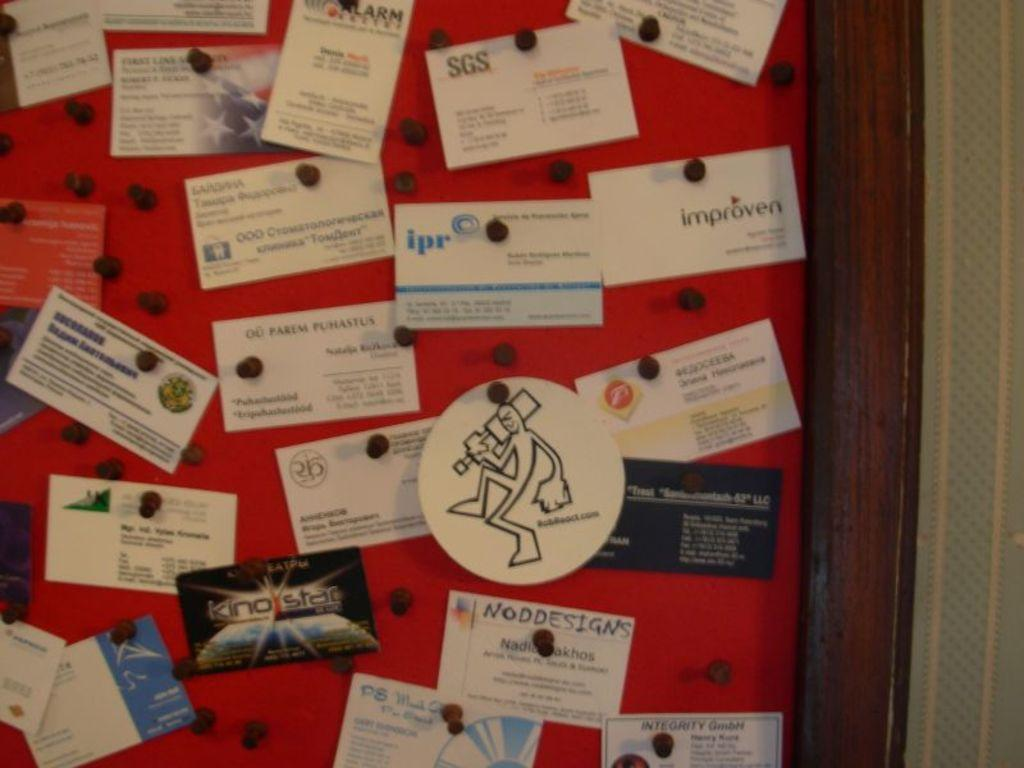<image>
Present a compact description of the photo's key features. A bulletin board with business cards on it, one of them is for improven. 